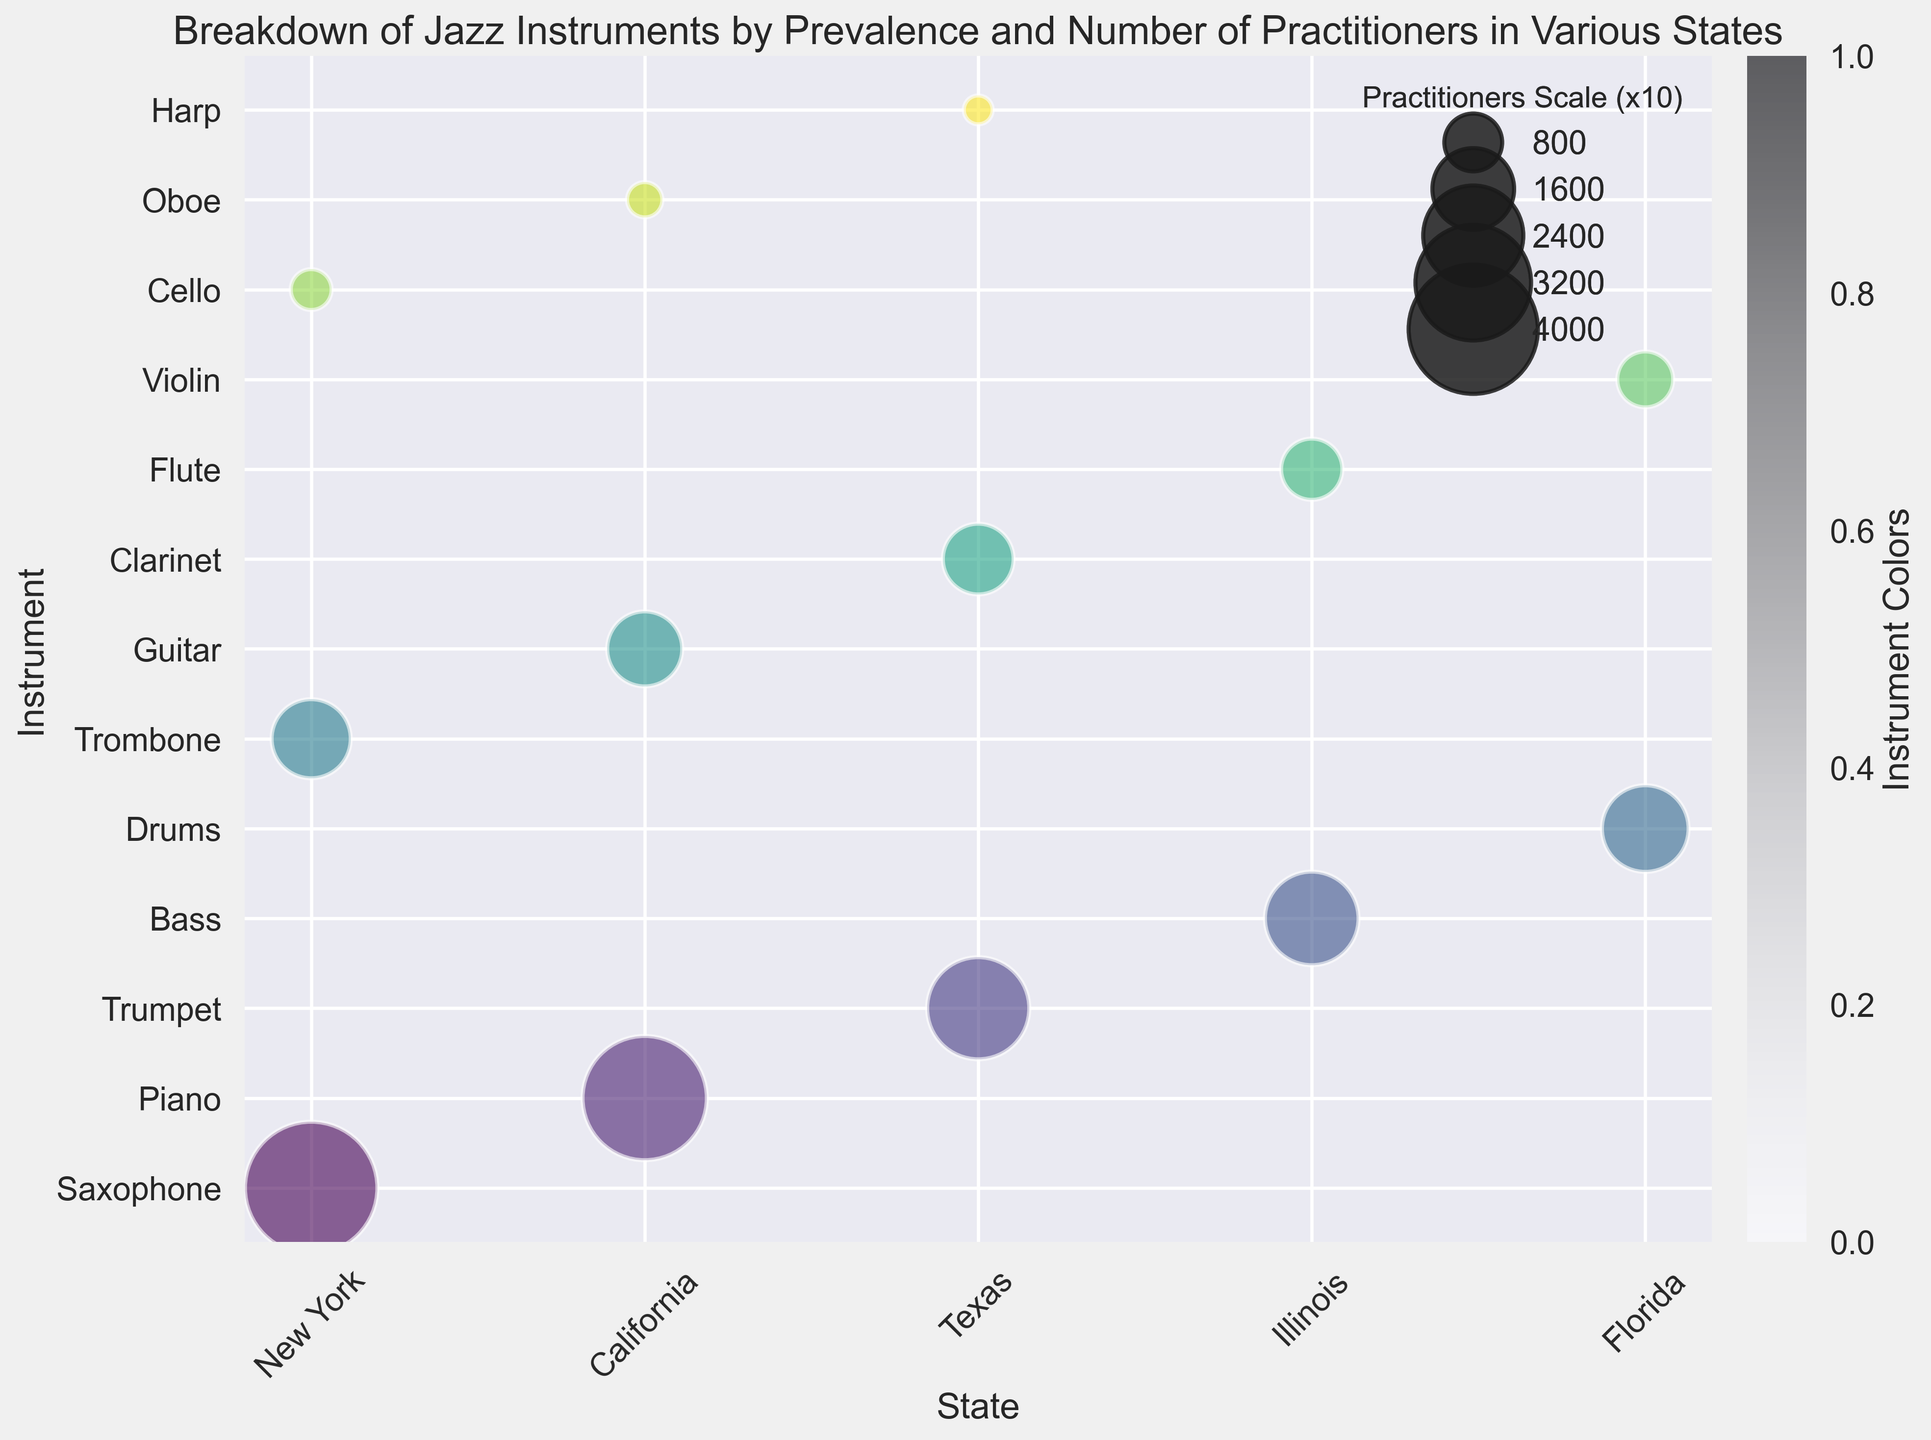Which state has the highest number of saxophone practitioners? Look for the bubble representing saxophone and compare its size across states. In New York, the saxophone bubble is the largest.
Answer: New York Which instrument has more practitioners in California: Guitar or Oboe? Compare the sizes of the bubbles for guitar and oboe in California. The guitar bubble is noticeably larger than the oboe bubble.
Answer: Guitar Which state has the lowest number of violin practitioners and what is the value? Identify the bubble representing violin in each state. Florida has the violin bubble and it's small.
Answer: Florida, 7500 Between New York and Texas, which state has a higher prevalence of trumpet players? Compare the prevalence values assigned to the bubbles for trumpet in New York and Texas. Texas has a Trumpet bubble and it's marked as Moderate. New York does not have a trumpet bubble.
Answer: Texas Are there more piano practitioners in California or more saxophone practitioners in New York? Compare the sizes of the bubbles for piano in California and saxophone in New York. The saxophone bubble is larger.
Answer: Saxophone in New York Which instrument in Florida has the least prevalence and what's the practitioner count? Identify the instrument with the smallest bubble in Florida and check its prevalence. The smallest bubble for violin has a low prevalence.
Answer: Violin, 7500 How many more practitioners of Bass are there in Illinois compared to Trombone practitioners in New York? Identify the sizes of the Bass bubble in Illinois (21000) and Trombone bubble in New York (15000). The difference is 21000 - 15000.
Answer: 6000 Which instrument is most prevalent in New York and which one has the highest number of practitioners? Look for the largest bubble in New York to determine practitioners (Saxophone, 42000) and highest prevalence (Saxophone, High).
Answer: Saxophone Compare the practitioners of Clarinet in Texas and Flute in Illinois. Which one has more practitioners? Look for the bubbles marked for Clarinet in Texas (12000) and Flute in Illinois (9000). The Clarinet bubble is larger.
Answer: Clarinet in Texas How many states have high-prevalence instruments and which are they? Identify all bubbles marked with 'High' and list the states: New York, California.
Answer: 2, New York, California 